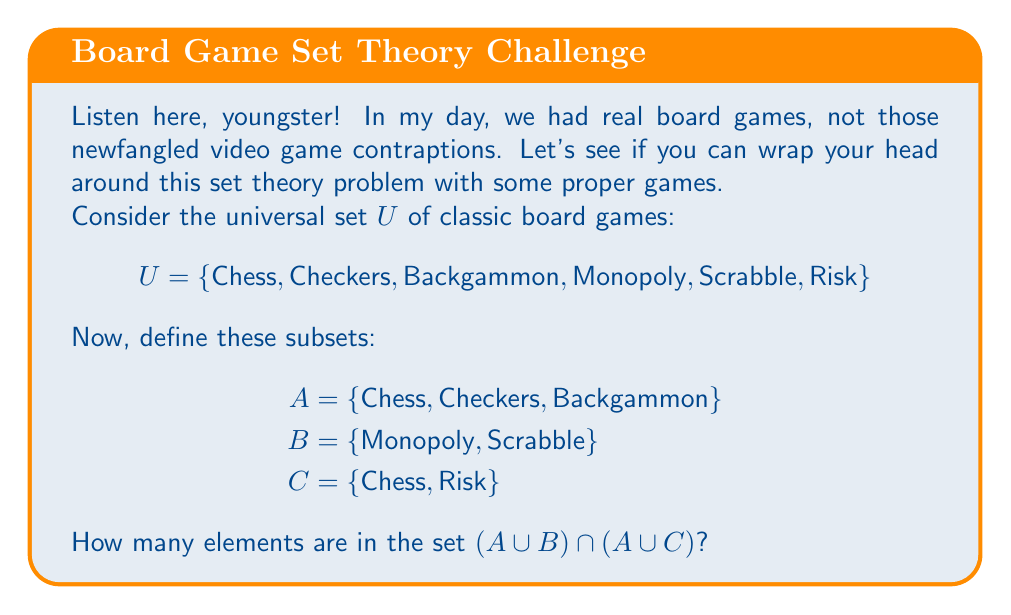Give your solution to this math problem. Alright, pay attention now. We'll solve this step-by-step, the proper way:

1) First, let's find $A \cup B$:
   $A \cup B = \{Chess, Checkers, Backgammon, Monopoly, Scrabble\}$

2) Next, let's find $A \cup C$:
   $A \cup C = \{Chess, Checkers, Backgammon, Risk\}$

3) Now, we need to find the intersection of these two sets:
   $(A \cup B) \cap (A \cup C)$

4) To do this, we identify the elements that are in both sets:
   $\{Chess, Checkers, Backgammon\}$

5) Finally, we count the elements in this resulting set:
   There are 3 elements in the set.

And there you have it. No need for fancy calculators or computers. Just good old-fashioned thinking!
Answer: 3 